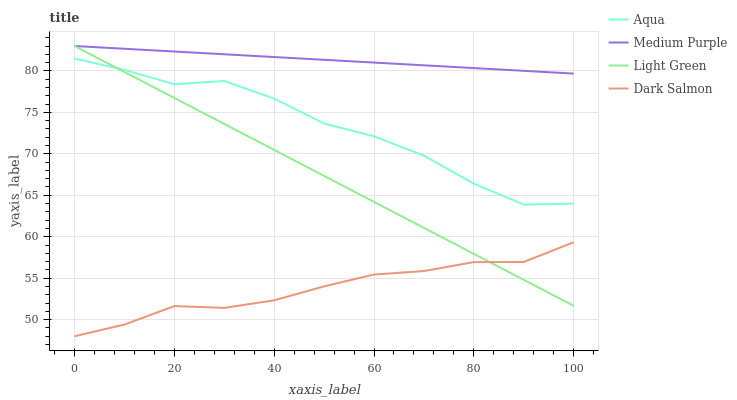Does Dark Salmon have the minimum area under the curve?
Answer yes or no. Yes. Does Medium Purple have the maximum area under the curve?
Answer yes or no. Yes. Does Aqua have the minimum area under the curve?
Answer yes or no. No. Does Aqua have the maximum area under the curve?
Answer yes or no. No. Is Light Green the smoothest?
Answer yes or no. Yes. Is Aqua the roughest?
Answer yes or no. Yes. Is Dark Salmon the smoothest?
Answer yes or no. No. Is Dark Salmon the roughest?
Answer yes or no. No. Does Dark Salmon have the lowest value?
Answer yes or no. Yes. Does Aqua have the lowest value?
Answer yes or no. No. Does Light Green have the highest value?
Answer yes or no. Yes. Does Aqua have the highest value?
Answer yes or no. No. Is Aqua less than Medium Purple?
Answer yes or no. Yes. Is Medium Purple greater than Aqua?
Answer yes or no. Yes. Does Dark Salmon intersect Light Green?
Answer yes or no. Yes. Is Dark Salmon less than Light Green?
Answer yes or no. No. Is Dark Salmon greater than Light Green?
Answer yes or no. No. Does Aqua intersect Medium Purple?
Answer yes or no. No. 